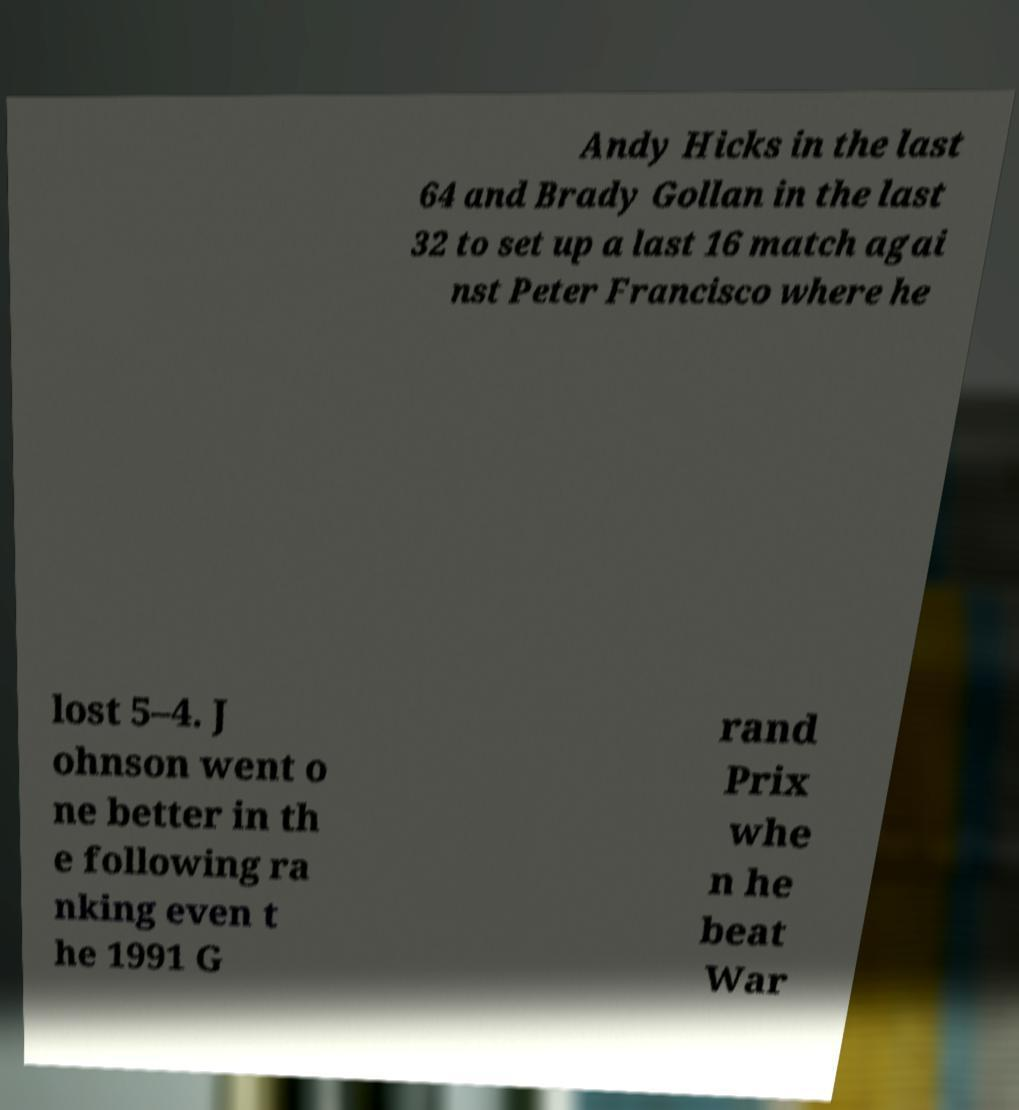Can you read and provide the text displayed in the image?This photo seems to have some interesting text. Can you extract and type it out for me? Andy Hicks in the last 64 and Brady Gollan in the last 32 to set up a last 16 match agai nst Peter Francisco where he lost 5–4. J ohnson went o ne better in th e following ra nking even t he 1991 G rand Prix whe n he beat War 